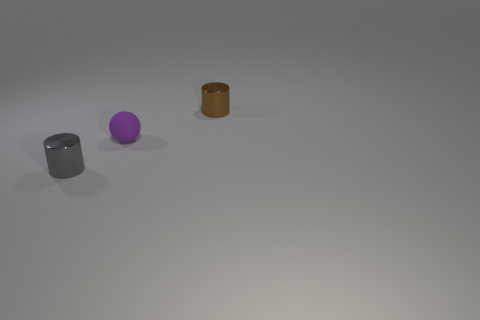Add 1 small brown metallic things. How many objects exist? 4 Subtract all balls. How many objects are left? 2 Subtract all small purple balls. Subtract all small brown metallic objects. How many objects are left? 1 Add 3 purple objects. How many purple objects are left? 4 Add 1 small red things. How many small red things exist? 1 Subtract 0 yellow cubes. How many objects are left? 3 